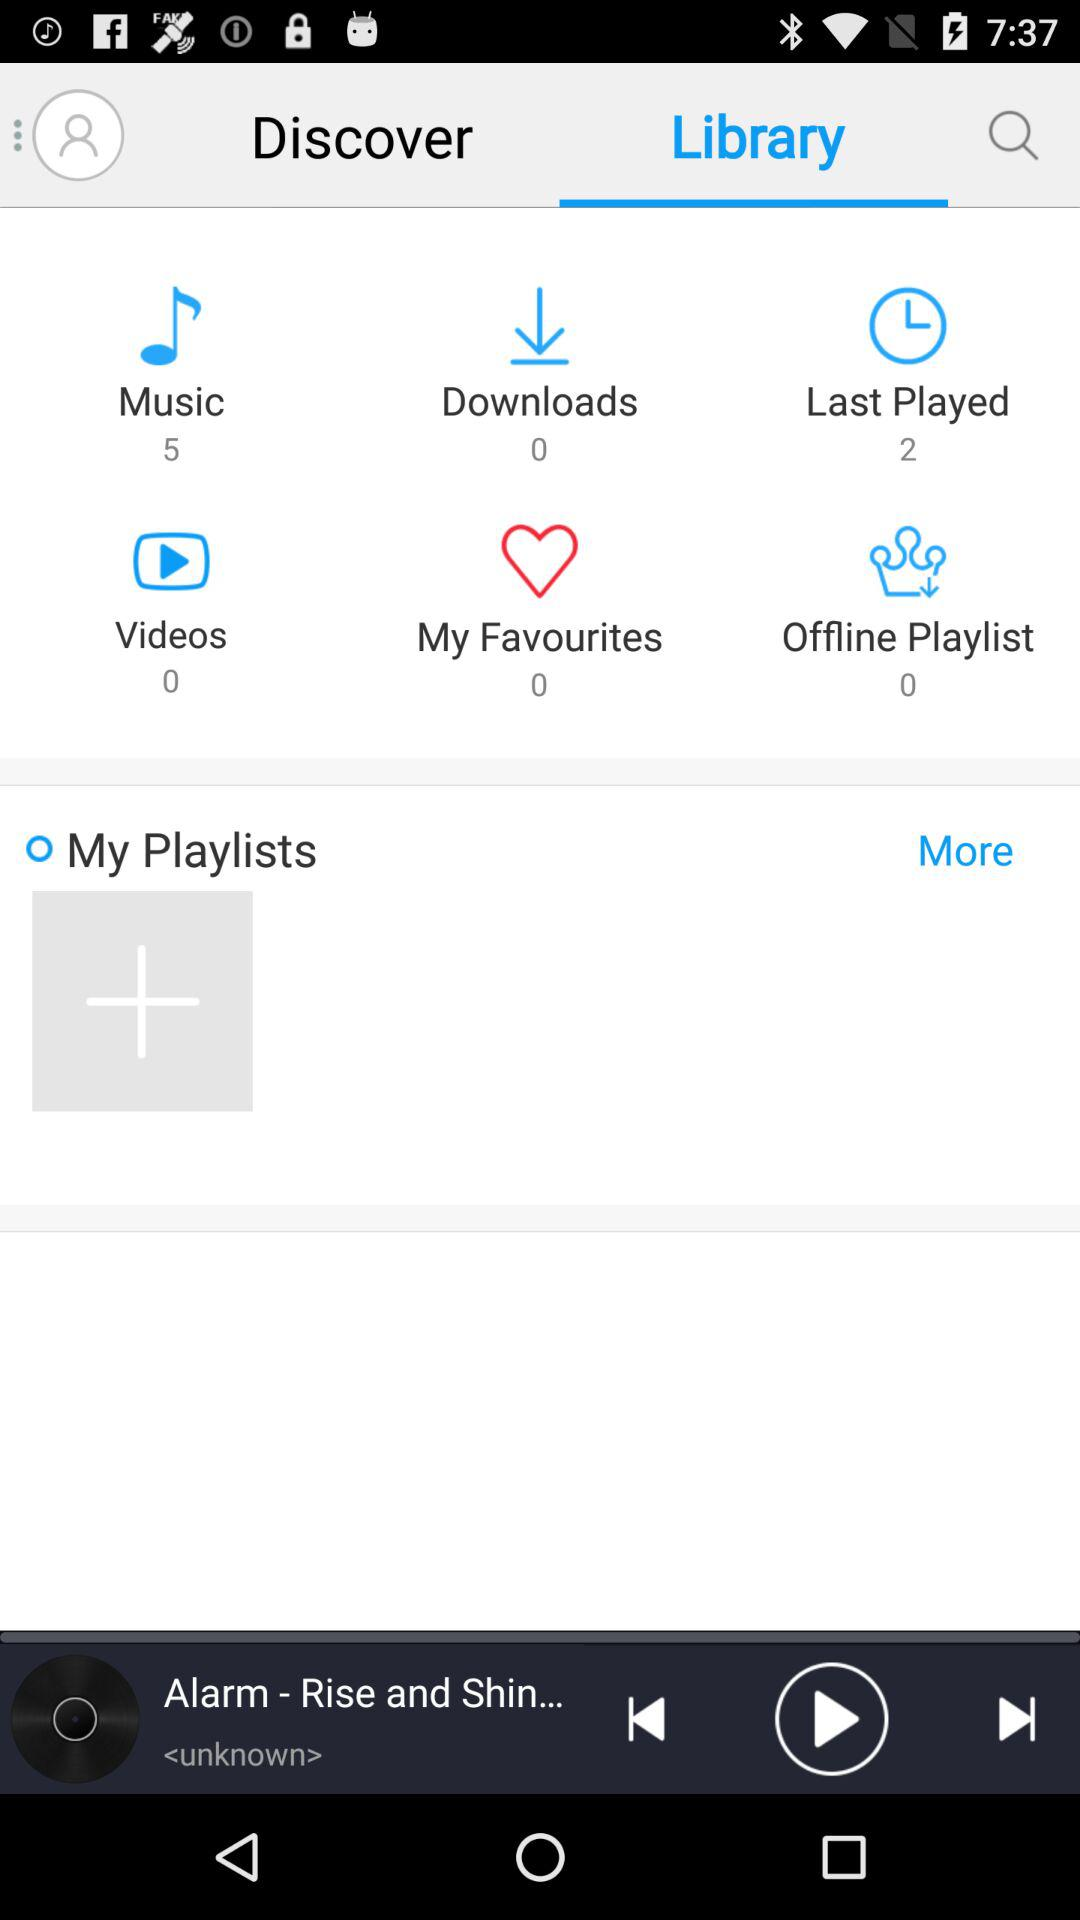What is the number of last played songs? The number of last played songs is 2. 